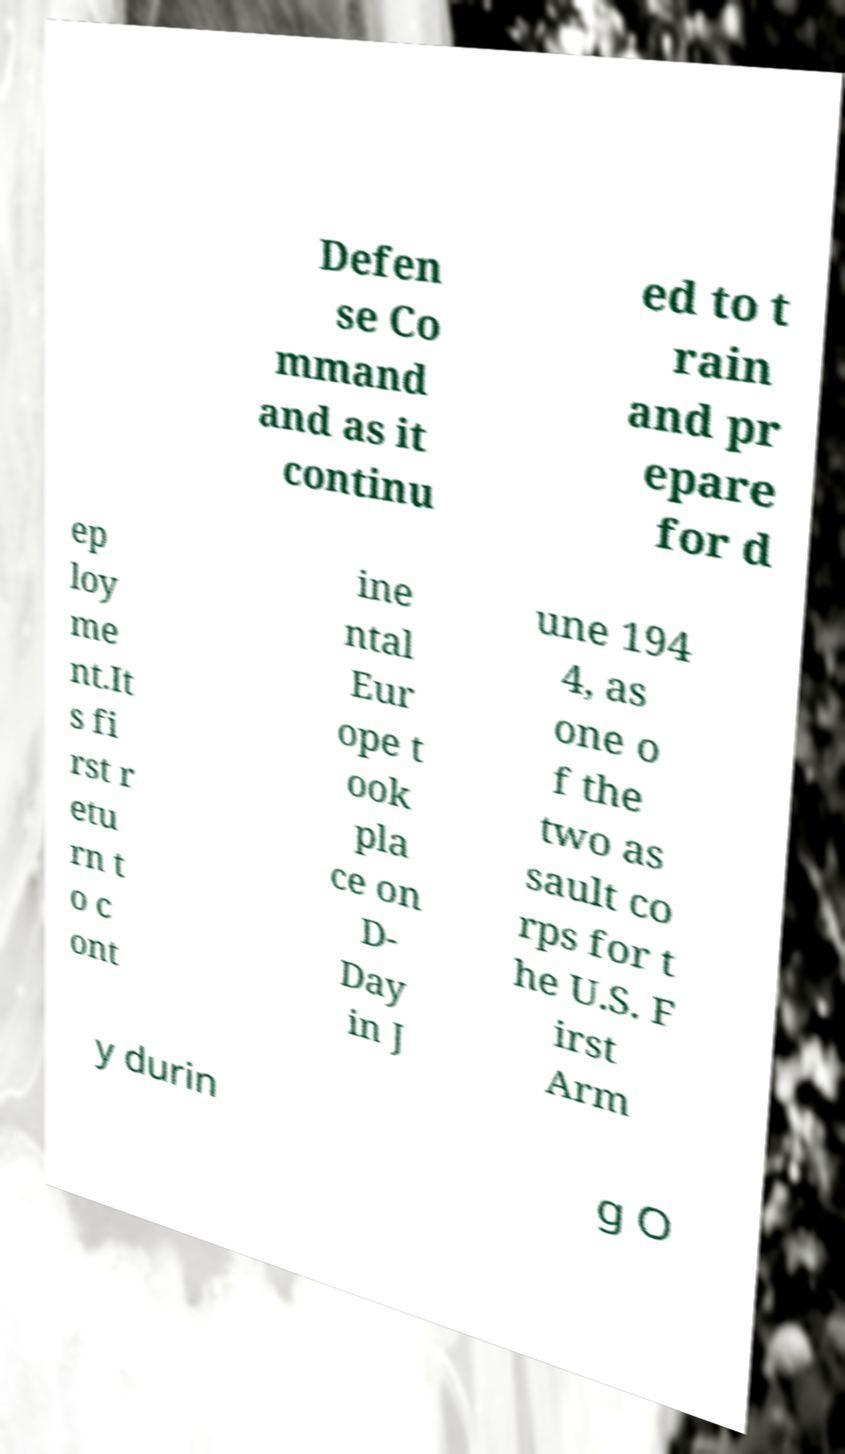Could you assist in decoding the text presented in this image and type it out clearly? Defen se Co mmand and as it continu ed to t rain and pr epare for d ep loy me nt.It s fi rst r etu rn t o c ont ine ntal Eur ope t ook pla ce on D- Day in J une 194 4, as one o f the two as sault co rps for t he U.S. F irst Arm y durin g O 